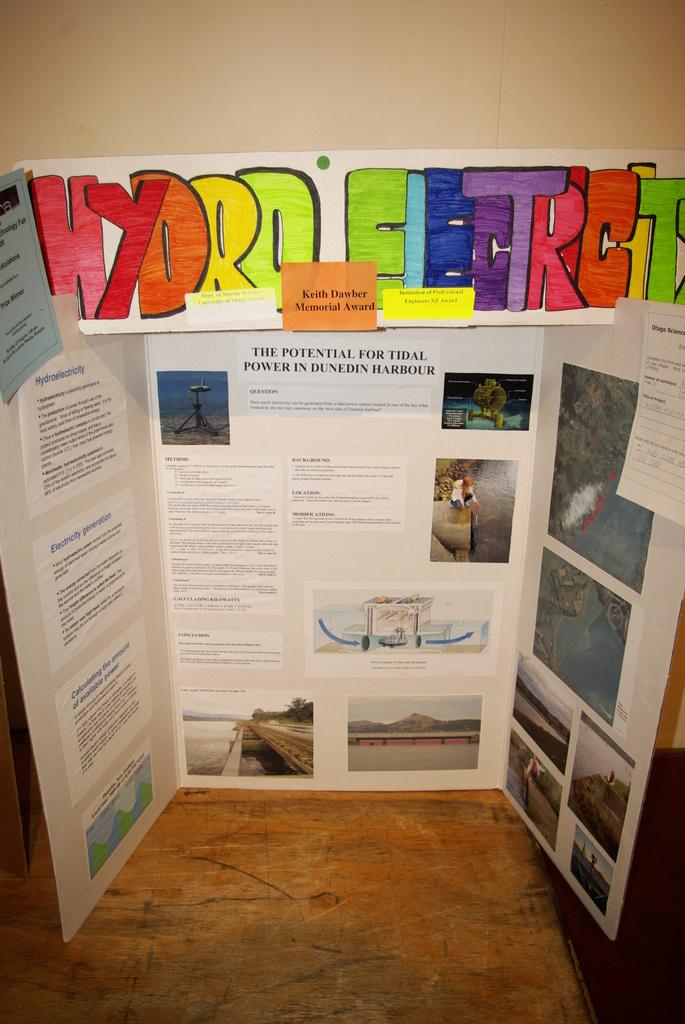<image>
Relay a brief, clear account of the picture shown. A hand made poster board presentation on hydro electricity. 